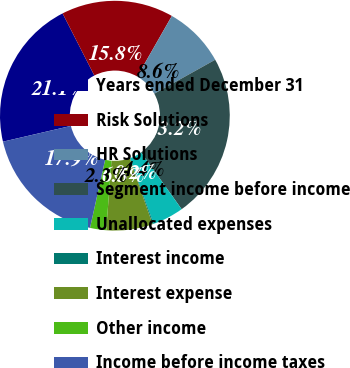Convert chart. <chart><loc_0><loc_0><loc_500><loc_500><pie_chart><fcel>Years ended December 31<fcel>Risk Solutions<fcel>HR Solutions<fcel>Segment income before income<fcel>Unallocated expenses<fcel>Interest income<fcel>Interest expense<fcel>Other income<fcel>Income before income taxes<nl><fcel>21.11%<fcel>15.78%<fcel>8.64%<fcel>23.23%<fcel>4.4%<fcel>0.15%<fcel>6.52%<fcel>2.27%<fcel>17.9%<nl></chart> 